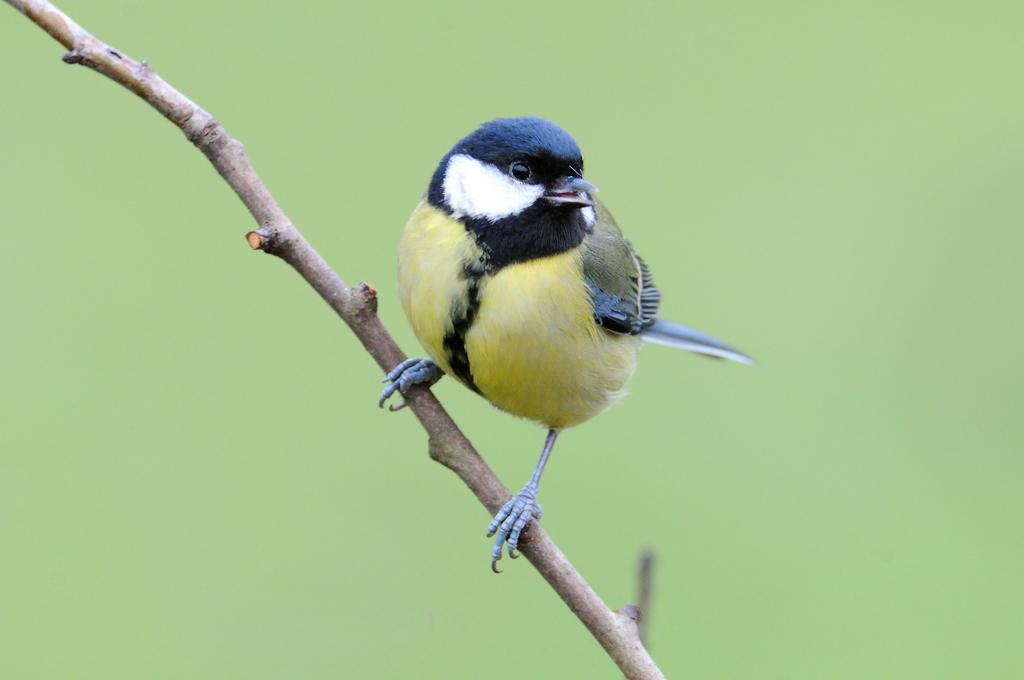What type of animal can be seen in the image? There is a bird in the image. Where is the bird located in the image? The bird is on a stem. How many pizzas are being weighed on the scale in the image? There is no scale or pizzas present in the image; it features a bird on a stem. 